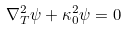<formula> <loc_0><loc_0><loc_500><loc_500>\nabla _ { T } ^ { 2 } \psi + \kappa _ { 0 } ^ { 2 } \psi = 0</formula> 